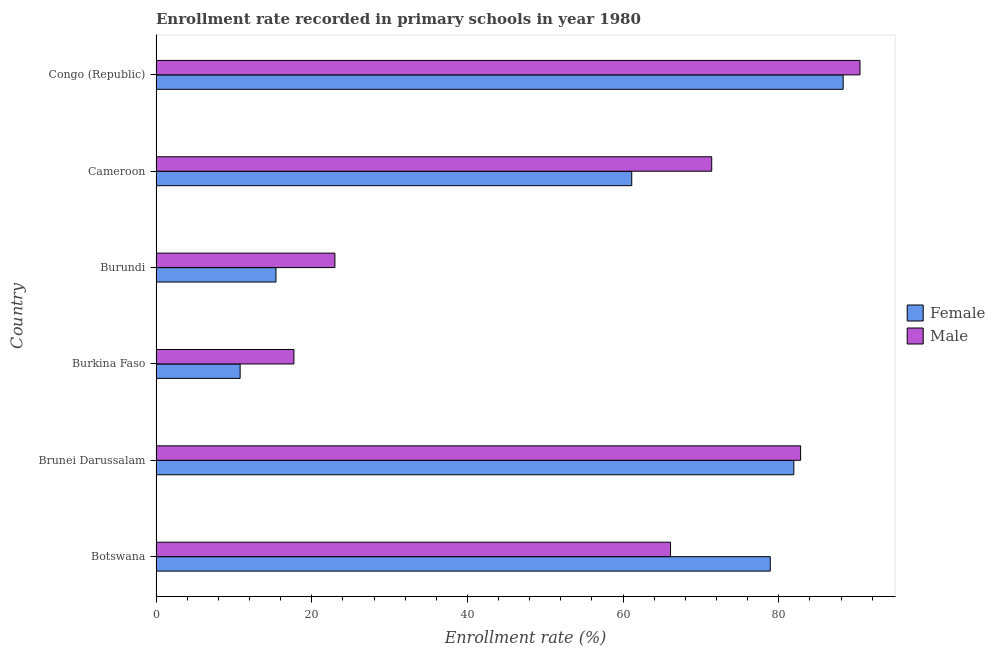Are the number of bars on each tick of the Y-axis equal?
Make the answer very short. Yes. How many bars are there on the 4th tick from the top?
Provide a short and direct response. 2. What is the label of the 4th group of bars from the top?
Offer a very short reply. Burkina Faso. What is the enrollment rate of female students in Cameroon?
Make the answer very short. 61.11. Across all countries, what is the maximum enrollment rate of male students?
Your answer should be very brief. 90.43. Across all countries, what is the minimum enrollment rate of female students?
Ensure brevity in your answer.  10.8. In which country was the enrollment rate of female students maximum?
Your answer should be very brief. Congo (Republic). In which country was the enrollment rate of male students minimum?
Give a very brief answer. Burkina Faso. What is the total enrollment rate of female students in the graph?
Your answer should be compact. 336.42. What is the difference between the enrollment rate of female students in Botswana and that in Cameroon?
Your answer should be very brief. 17.8. What is the difference between the enrollment rate of male students in Botswana and the enrollment rate of female students in Brunei Darussalam?
Make the answer very short. -15.84. What is the average enrollment rate of female students per country?
Keep it short and to the point. 56.07. What is the difference between the enrollment rate of male students and enrollment rate of female students in Botswana?
Keep it short and to the point. -12.81. In how many countries, is the enrollment rate of female students greater than 80 %?
Your response must be concise. 2. What is the ratio of the enrollment rate of male students in Cameroon to that in Congo (Republic)?
Make the answer very short. 0.79. Is the enrollment rate of female students in Botswana less than that in Burkina Faso?
Keep it short and to the point. No. What is the difference between the highest and the second highest enrollment rate of male students?
Your answer should be very brief. 7.63. What is the difference between the highest and the lowest enrollment rate of male students?
Give a very brief answer. 72.71. In how many countries, is the enrollment rate of female students greater than the average enrollment rate of female students taken over all countries?
Give a very brief answer. 4. Is the sum of the enrollment rate of female students in Burkina Faso and Congo (Republic) greater than the maximum enrollment rate of male students across all countries?
Your response must be concise. Yes. How many bars are there?
Ensure brevity in your answer.  12. How many countries are there in the graph?
Offer a terse response. 6. Are the values on the major ticks of X-axis written in scientific E-notation?
Offer a very short reply. No. Where does the legend appear in the graph?
Your response must be concise. Center right. What is the title of the graph?
Your answer should be very brief. Enrollment rate recorded in primary schools in year 1980. What is the label or title of the X-axis?
Your answer should be very brief. Enrollment rate (%). What is the label or title of the Y-axis?
Your answer should be very brief. Country. What is the Enrollment rate (%) in Female in Botswana?
Provide a short and direct response. 78.9. What is the Enrollment rate (%) in Male in Botswana?
Make the answer very short. 66.09. What is the Enrollment rate (%) of Female in Brunei Darussalam?
Provide a succinct answer. 81.93. What is the Enrollment rate (%) of Male in Brunei Darussalam?
Offer a very short reply. 82.8. What is the Enrollment rate (%) in Female in Burkina Faso?
Your answer should be very brief. 10.8. What is the Enrollment rate (%) of Male in Burkina Faso?
Provide a short and direct response. 17.71. What is the Enrollment rate (%) of Female in Burundi?
Give a very brief answer. 15.41. What is the Enrollment rate (%) in Male in Burundi?
Provide a succinct answer. 22.98. What is the Enrollment rate (%) of Female in Cameroon?
Make the answer very short. 61.11. What is the Enrollment rate (%) of Male in Cameroon?
Give a very brief answer. 71.38. What is the Enrollment rate (%) of Female in Congo (Republic)?
Give a very brief answer. 88.27. What is the Enrollment rate (%) of Male in Congo (Republic)?
Provide a succinct answer. 90.43. Across all countries, what is the maximum Enrollment rate (%) of Female?
Provide a short and direct response. 88.27. Across all countries, what is the maximum Enrollment rate (%) in Male?
Your answer should be very brief. 90.43. Across all countries, what is the minimum Enrollment rate (%) in Female?
Give a very brief answer. 10.8. Across all countries, what is the minimum Enrollment rate (%) in Male?
Give a very brief answer. 17.71. What is the total Enrollment rate (%) in Female in the graph?
Your answer should be very brief. 336.42. What is the total Enrollment rate (%) in Male in the graph?
Offer a terse response. 351.4. What is the difference between the Enrollment rate (%) of Female in Botswana and that in Brunei Darussalam?
Offer a very short reply. -3.02. What is the difference between the Enrollment rate (%) of Male in Botswana and that in Brunei Darussalam?
Provide a succinct answer. -16.71. What is the difference between the Enrollment rate (%) of Female in Botswana and that in Burkina Faso?
Keep it short and to the point. 68.1. What is the difference between the Enrollment rate (%) in Male in Botswana and that in Burkina Faso?
Your response must be concise. 48.38. What is the difference between the Enrollment rate (%) of Female in Botswana and that in Burundi?
Make the answer very short. 63.5. What is the difference between the Enrollment rate (%) of Male in Botswana and that in Burundi?
Offer a very short reply. 43.11. What is the difference between the Enrollment rate (%) in Female in Botswana and that in Cameroon?
Ensure brevity in your answer.  17.8. What is the difference between the Enrollment rate (%) of Male in Botswana and that in Cameroon?
Give a very brief answer. -5.29. What is the difference between the Enrollment rate (%) of Female in Botswana and that in Congo (Republic)?
Offer a terse response. -9.36. What is the difference between the Enrollment rate (%) of Male in Botswana and that in Congo (Republic)?
Your answer should be very brief. -24.33. What is the difference between the Enrollment rate (%) in Female in Brunei Darussalam and that in Burkina Faso?
Offer a terse response. 71.12. What is the difference between the Enrollment rate (%) in Male in Brunei Darussalam and that in Burkina Faso?
Offer a very short reply. 65.09. What is the difference between the Enrollment rate (%) in Female in Brunei Darussalam and that in Burundi?
Keep it short and to the point. 66.52. What is the difference between the Enrollment rate (%) in Male in Brunei Darussalam and that in Burundi?
Keep it short and to the point. 59.82. What is the difference between the Enrollment rate (%) in Female in Brunei Darussalam and that in Cameroon?
Offer a very short reply. 20.82. What is the difference between the Enrollment rate (%) of Male in Brunei Darussalam and that in Cameroon?
Provide a succinct answer. 11.42. What is the difference between the Enrollment rate (%) in Female in Brunei Darussalam and that in Congo (Republic)?
Give a very brief answer. -6.34. What is the difference between the Enrollment rate (%) of Male in Brunei Darussalam and that in Congo (Republic)?
Give a very brief answer. -7.63. What is the difference between the Enrollment rate (%) of Female in Burkina Faso and that in Burundi?
Offer a very short reply. -4.6. What is the difference between the Enrollment rate (%) of Male in Burkina Faso and that in Burundi?
Ensure brevity in your answer.  -5.27. What is the difference between the Enrollment rate (%) in Female in Burkina Faso and that in Cameroon?
Make the answer very short. -50.3. What is the difference between the Enrollment rate (%) in Male in Burkina Faso and that in Cameroon?
Your answer should be very brief. -53.67. What is the difference between the Enrollment rate (%) of Female in Burkina Faso and that in Congo (Republic)?
Offer a very short reply. -77.46. What is the difference between the Enrollment rate (%) of Male in Burkina Faso and that in Congo (Republic)?
Keep it short and to the point. -72.71. What is the difference between the Enrollment rate (%) of Female in Burundi and that in Cameroon?
Your response must be concise. -45.7. What is the difference between the Enrollment rate (%) in Male in Burundi and that in Cameroon?
Your response must be concise. -48.4. What is the difference between the Enrollment rate (%) in Female in Burundi and that in Congo (Republic)?
Your answer should be compact. -72.86. What is the difference between the Enrollment rate (%) in Male in Burundi and that in Congo (Republic)?
Provide a succinct answer. -67.45. What is the difference between the Enrollment rate (%) of Female in Cameroon and that in Congo (Republic)?
Offer a terse response. -27.16. What is the difference between the Enrollment rate (%) in Male in Cameroon and that in Congo (Republic)?
Provide a succinct answer. -19.05. What is the difference between the Enrollment rate (%) of Female in Botswana and the Enrollment rate (%) of Male in Brunei Darussalam?
Ensure brevity in your answer.  -3.9. What is the difference between the Enrollment rate (%) in Female in Botswana and the Enrollment rate (%) in Male in Burkina Faso?
Keep it short and to the point. 61.19. What is the difference between the Enrollment rate (%) in Female in Botswana and the Enrollment rate (%) in Male in Burundi?
Offer a terse response. 55.93. What is the difference between the Enrollment rate (%) of Female in Botswana and the Enrollment rate (%) of Male in Cameroon?
Your answer should be compact. 7.52. What is the difference between the Enrollment rate (%) in Female in Botswana and the Enrollment rate (%) in Male in Congo (Republic)?
Give a very brief answer. -11.52. What is the difference between the Enrollment rate (%) in Female in Brunei Darussalam and the Enrollment rate (%) in Male in Burkina Faso?
Offer a terse response. 64.21. What is the difference between the Enrollment rate (%) in Female in Brunei Darussalam and the Enrollment rate (%) in Male in Burundi?
Offer a very short reply. 58.95. What is the difference between the Enrollment rate (%) of Female in Brunei Darussalam and the Enrollment rate (%) of Male in Cameroon?
Offer a very short reply. 10.55. What is the difference between the Enrollment rate (%) of Female in Brunei Darussalam and the Enrollment rate (%) of Male in Congo (Republic)?
Provide a short and direct response. -8.5. What is the difference between the Enrollment rate (%) in Female in Burkina Faso and the Enrollment rate (%) in Male in Burundi?
Your response must be concise. -12.17. What is the difference between the Enrollment rate (%) of Female in Burkina Faso and the Enrollment rate (%) of Male in Cameroon?
Your response must be concise. -60.58. What is the difference between the Enrollment rate (%) of Female in Burkina Faso and the Enrollment rate (%) of Male in Congo (Republic)?
Keep it short and to the point. -79.62. What is the difference between the Enrollment rate (%) of Female in Burundi and the Enrollment rate (%) of Male in Cameroon?
Provide a short and direct response. -55.97. What is the difference between the Enrollment rate (%) of Female in Burundi and the Enrollment rate (%) of Male in Congo (Republic)?
Your answer should be very brief. -75.02. What is the difference between the Enrollment rate (%) of Female in Cameroon and the Enrollment rate (%) of Male in Congo (Republic)?
Give a very brief answer. -29.32. What is the average Enrollment rate (%) in Female per country?
Ensure brevity in your answer.  56.07. What is the average Enrollment rate (%) of Male per country?
Your answer should be compact. 58.57. What is the difference between the Enrollment rate (%) of Female and Enrollment rate (%) of Male in Botswana?
Ensure brevity in your answer.  12.81. What is the difference between the Enrollment rate (%) of Female and Enrollment rate (%) of Male in Brunei Darussalam?
Your response must be concise. -0.87. What is the difference between the Enrollment rate (%) of Female and Enrollment rate (%) of Male in Burkina Faso?
Keep it short and to the point. -6.91. What is the difference between the Enrollment rate (%) of Female and Enrollment rate (%) of Male in Burundi?
Make the answer very short. -7.57. What is the difference between the Enrollment rate (%) in Female and Enrollment rate (%) in Male in Cameroon?
Offer a terse response. -10.27. What is the difference between the Enrollment rate (%) of Female and Enrollment rate (%) of Male in Congo (Republic)?
Make the answer very short. -2.16. What is the ratio of the Enrollment rate (%) of Female in Botswana to that in Brunei Darussalam?
Ensure brevity in your answer.  0.96. What is the ratio of the Enrollment rate (%) of Male in Botswana to that in Brunei Darussalam?
Offer a very short reply. 0.8. What is the ratio of the Enrollment rate (%) in Female in Botswana to that in Burkina Faso?
Your answer should be compact. 7.3. What is the ratio of the Enrollment rate (%) of Male in Botswana to that in Burkina Faso?
Your answer should be compact. 3.73. What is the ratio of the Enrollment rate (%) in Female in Botswana to that in Burundi?
Your answer should be compact. 5.12. What is the ratio of the Enrollment rate (%) of Male in Botswana to that in Burundi?
Ensure brevity in your answer.  2.88. What is the ratio of the Enrollment rate (%) of Female in Botswana to that in Cameroon?
Give a very brief answer. 1.29. What is the ratio of the Enrollment rate (%) in Male in Botswana to that in Cameroon?
Give a very brief answer. 0.93. What is the ratio of the Enrollment rate (%) in Female in Botswana to that in Congo (Republic)?
Your answer should be compact. 0.89. What is the ratio of the Enrollment rate (%) of Male in Botswana to that in Congo (Republic)?
Give a very brief answer. 0.73. What is the ratio of the Enrollment rate (%) in Female in Brunei Darussalam to that in Burkina Faso?
Offer a terse response. 7.58. What is the ratio of the Enrollment rate (%) in Male in Brunei Darussalam to that in Burkina Faso?
Keep it short and to the point. 4.67. What is the ratio of the Enrollment rate (%) in Female in Brunei Darussalam to that in Burundi?
Ensure brevity in your answer.  5.32. What is the ratio of the Enrollment rate (%) of Male in Brunei Darussalam to that in Burundi?
Make the answer very short. 3.6. What is the ratio of the Enrollment rate (%) in Female in Brunei Darussalam to that in Cameroon?
Ensure brevity in your answer.  1.34. What is the ratio of the Enrollment rate (%) in Male in Brunei Darussalam to that in Cameroon?
Your answer should be very brief. 1.16. What is the ratio of the Enrollment rate (%) of Female in Brunei Darussalam to that in Congo (Republic)?
Your answer should be very brief. 0.93. What is the ratio of the Enrollment rate (%) of Male in Brunei Darussalam to that in Congo (Republic)?
Provide a succinct answer. 0.92. What is the ratio of the Enrollment rate (%) in Female in Burkina Faso to that in Burundi?
Your answer should be compact. 0.7. What is the ratio of the Enrollment rate (%) in Male in Burkina Faso to that in Burundi?
Give a very brief answer. 0.77. What is the ratio of the Enrollment rate (%) in Female in Burkina Faso to that in Cameroon?
Offer a very short reply. 0.18. What is the ratio of the Enrollment rate (%) of Male in Burkina Faso to that in Cameroon?
Your answer should be very brief. 0.25. What is the ratio of the Enrollment rate (%) of Female in Burkina Faso to that in Congo (Republic)?
Your response must be concise. 0.12. What is the ratio of the Enrollment rate (%) of Male in Burkina Faso to that in Congo (Republic)?
Ensure brevity in your answer.  0.2. What is the ratio of the Enrollment rate (%) in Female in Burundi to that in Cameroon?
Give a very brief answer. 0.25. What is the ratio of the Enrollment rate (%) of Male in Burundi to that in Cameroon?
Offer a terse response. 0.32. What is the ratio of the Enrollment rate (%) in Female in Burundi to that in Congo (Republic)?
Provide a succinct answer. 0.17. What is the ratio of the Enrollment rate (%) in Male in Burundi to that in Congo (Republic)?
Ensure brevity in your answer.  0.25. What is the ratio of the Enrollment rate (%) in Female in Cameroon to that in Congo (Republic)?
Make the answer very short. 0.69. What is the ratio of the Enrollment rate (%) in Male in Cameroon to that in Congo (Republic)?
Offer a very short reply. 0.79. What is the difference between the highest and the second highest Enrollment rate (%) of Female?
Your answer should be compact. 6.34. What is the difference between the highest and the second highest Enrollment rate (%) of Male?
Provide a succinct answer. 7.63. What is the difference between the highest and the lowest Enrollment rate (%) of Female?
Your response must be concise. 77.46. What is the difference between the highest and the lowest Enrollment rate (%) in Male?
Provide a succinct answer. 72.71. 